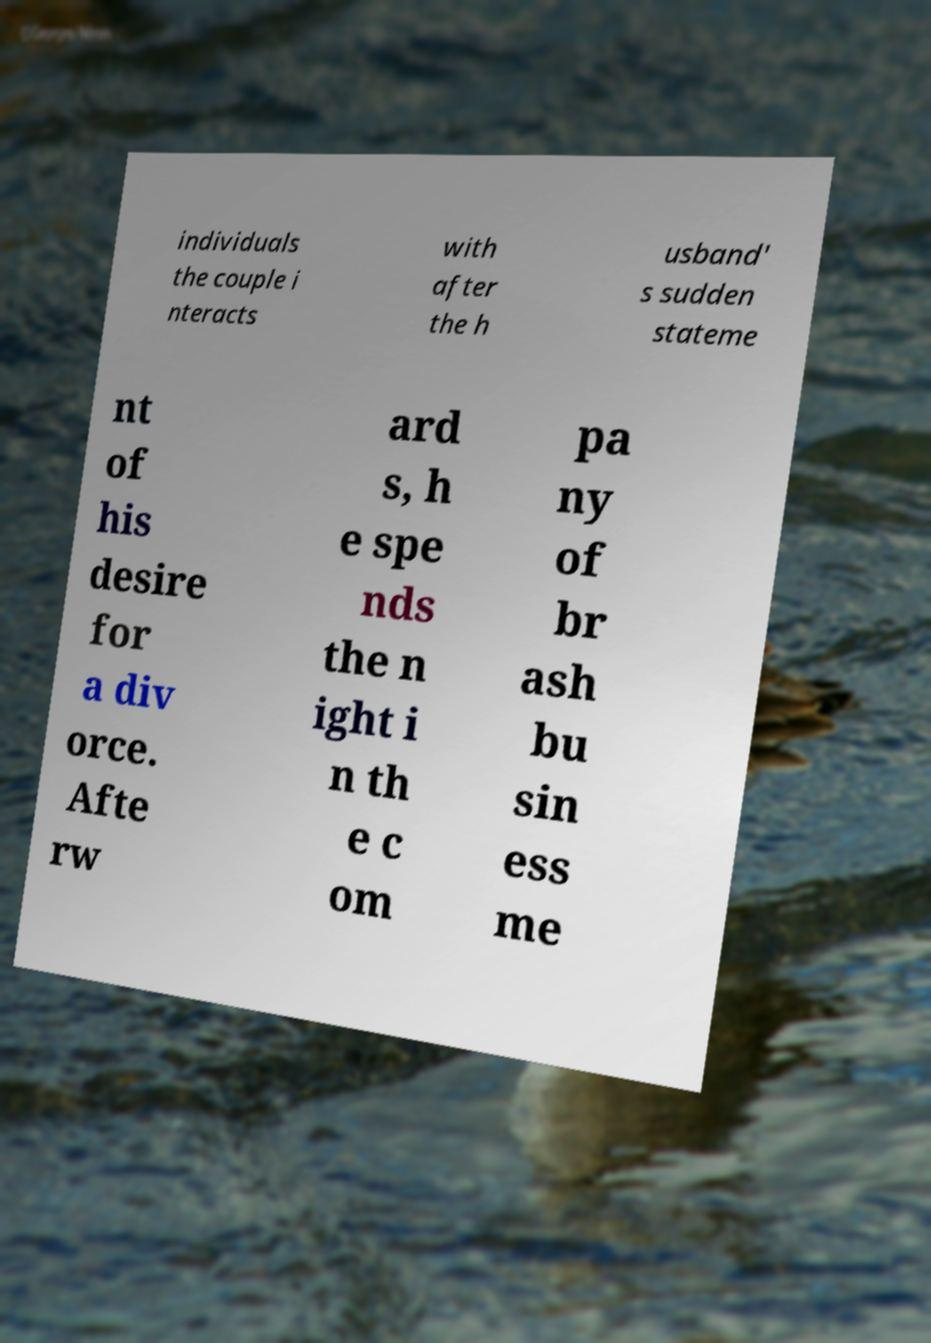Please read and relay the text visible in this image. What does it say? individuals the couple i nteracts with after the h usband' s sudden stateme nt of his desire for a div orce. Afte rw ard s, h e spe nds the n ight i n th e c om pa ny of br ash bu sin ess me 